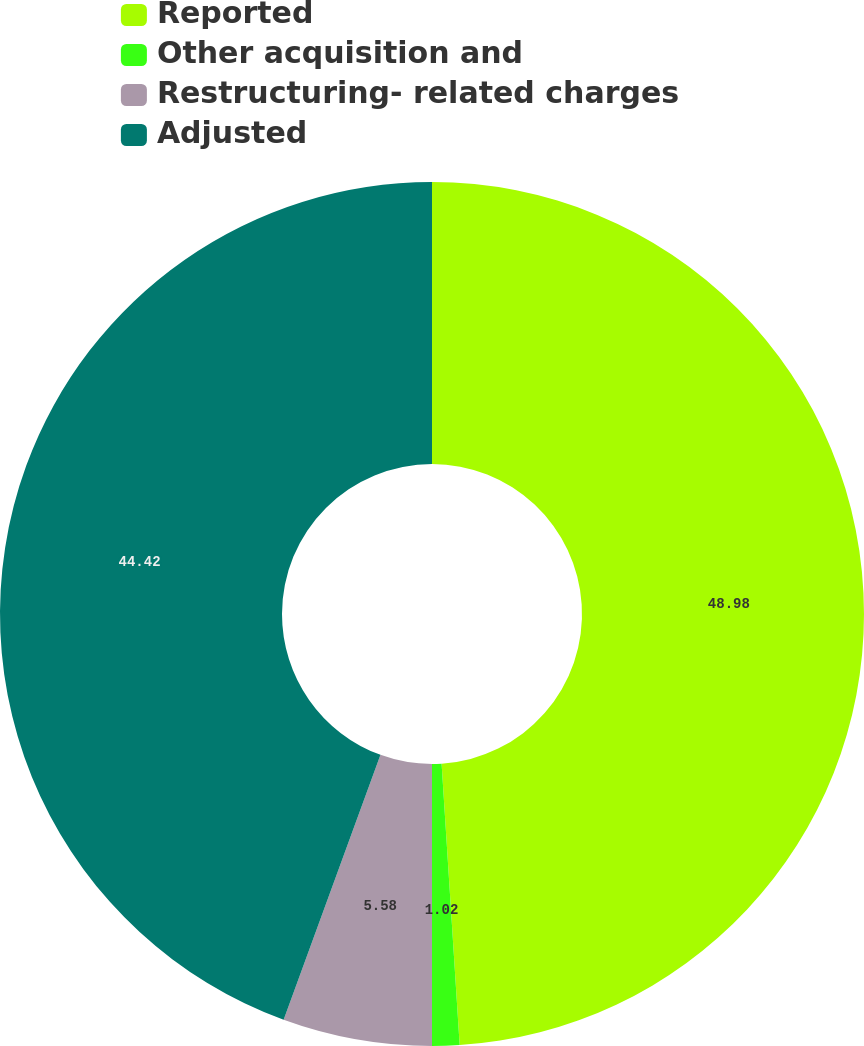Convert chart to OTSL. <chart><loc_0><loc_0><loc_500><loc_500><pie_chart><fcel>Reported<fcel>Other acquisition and<fcel>Restructuring- related charges<fcel>Adjusted<nl><fcel>48.98%<fcel>1.02%<fcel>5.58%<fcel>44.42%<nl></chart> 